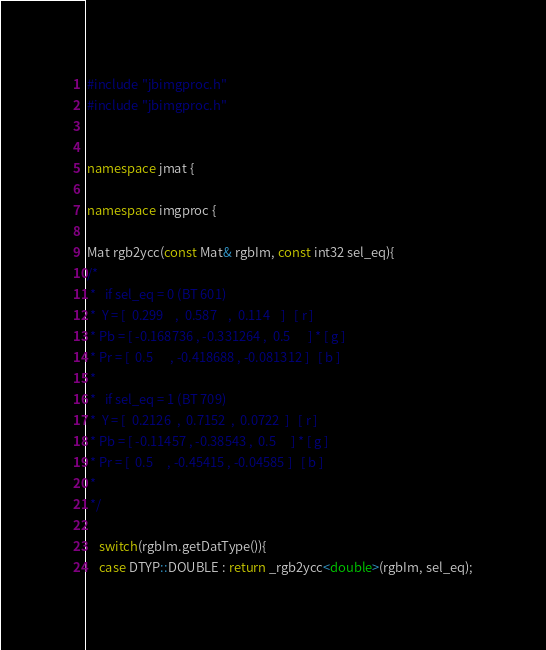Convert code to text. <code><loc_0><loc_0><loc_500><loc_500><_C++_>#include "jbimgproc.h"
#include "jbimgproc.h"


namespace jmat {

namespace imgproc {

Mat rgb2ycc(const Mat& rgbIm, const int32 sel_eq){
/*
 *   if sel_eq = 0 (BT 601)
 *  Y = [  0.299    ,  0.587    ,  0.114    ]   [ r ]
 * Pb = [ -0.168736 , -0.331264 ,  0.5      ] * [ g ]
 * Pr = [  0.5      , -0.418688 , -0.081312 ]   [ b ]
 *
 *   if sel_eq = 1 (BT 709)
 *  Y = [  0.2126  ,  0.7152  ,  0.0722  ]   [ r ]
 * Pb = [ -0.11457 , -0.38543 ,	 0.5     ] * [ g ]
 * Pr = [  0.5     , -0.45415 ,	-0.04585 ]   [ b ]
 *
 */

    switch(rgbIm.getDatType()){
    case DTYP::DOUBLE : return _rgb2ycc<double>(rgbIm, sel_eq);</code> 